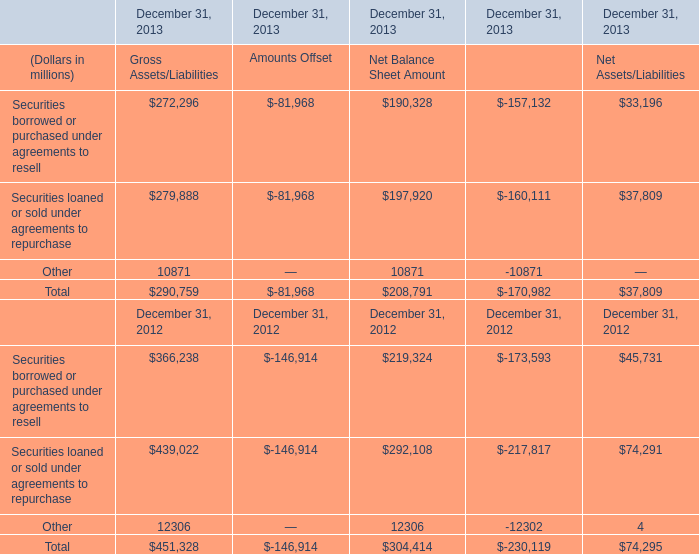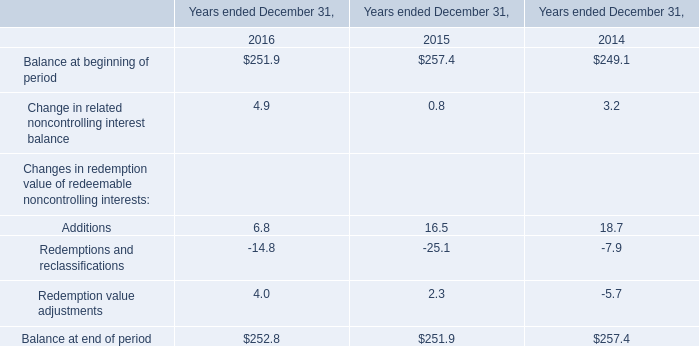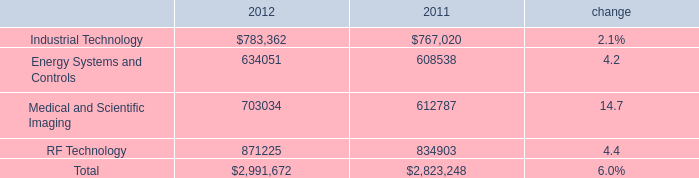What was the average of the Securities loaned or sold under agreements to repurchase for Gross Assets/Liabilities in the years where Gross Assets/Liabilities is positive? (in million) 
Computations: ((279888 + 439022) / 2)
Answer: 359455.0. 